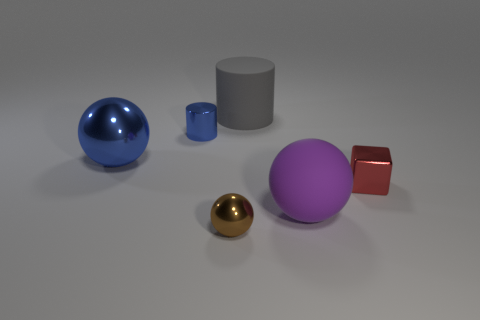How many other objects are the same shape as the brown object?
Your answer should be compact. 2. There is a thing that is in front of the rubber object in front of the cylinder right of the small brown ball; what is it made of?
Give a very brief answer. Metal. Are there the same number of big metal things in front of the matte sphere and tiny blue objects?
Give a very brief answer. No. Does the sphere on the right side of the large gray cylinder have the same material as the object that is in front of the large purple sphere?
Provide a short and direct response. No. Are there any other things that have the same material as the large blue ball?
Offer a terse response. Yes. Does the red thing that is behind the matte sphere have the same shape as the blue object that is on the right side of the large shiny ball?
Offer a terse response. No. Is the number of small blue cylinders that are right of the gray matte object less than the number of big blue objects?
Ensure brevity in your answer.  Yes. What number of objects have the same color as the rubber cylinder?
Give a very brief answer. 0. What size is the blue thing that is on the right side of the big blue object?
Give a very brief answer. Small. What is the shape of the large thing that is to the left of the big matte thing that is behind the big thing in front of the blue metal ball?
Make the answer very short. Sphere. 